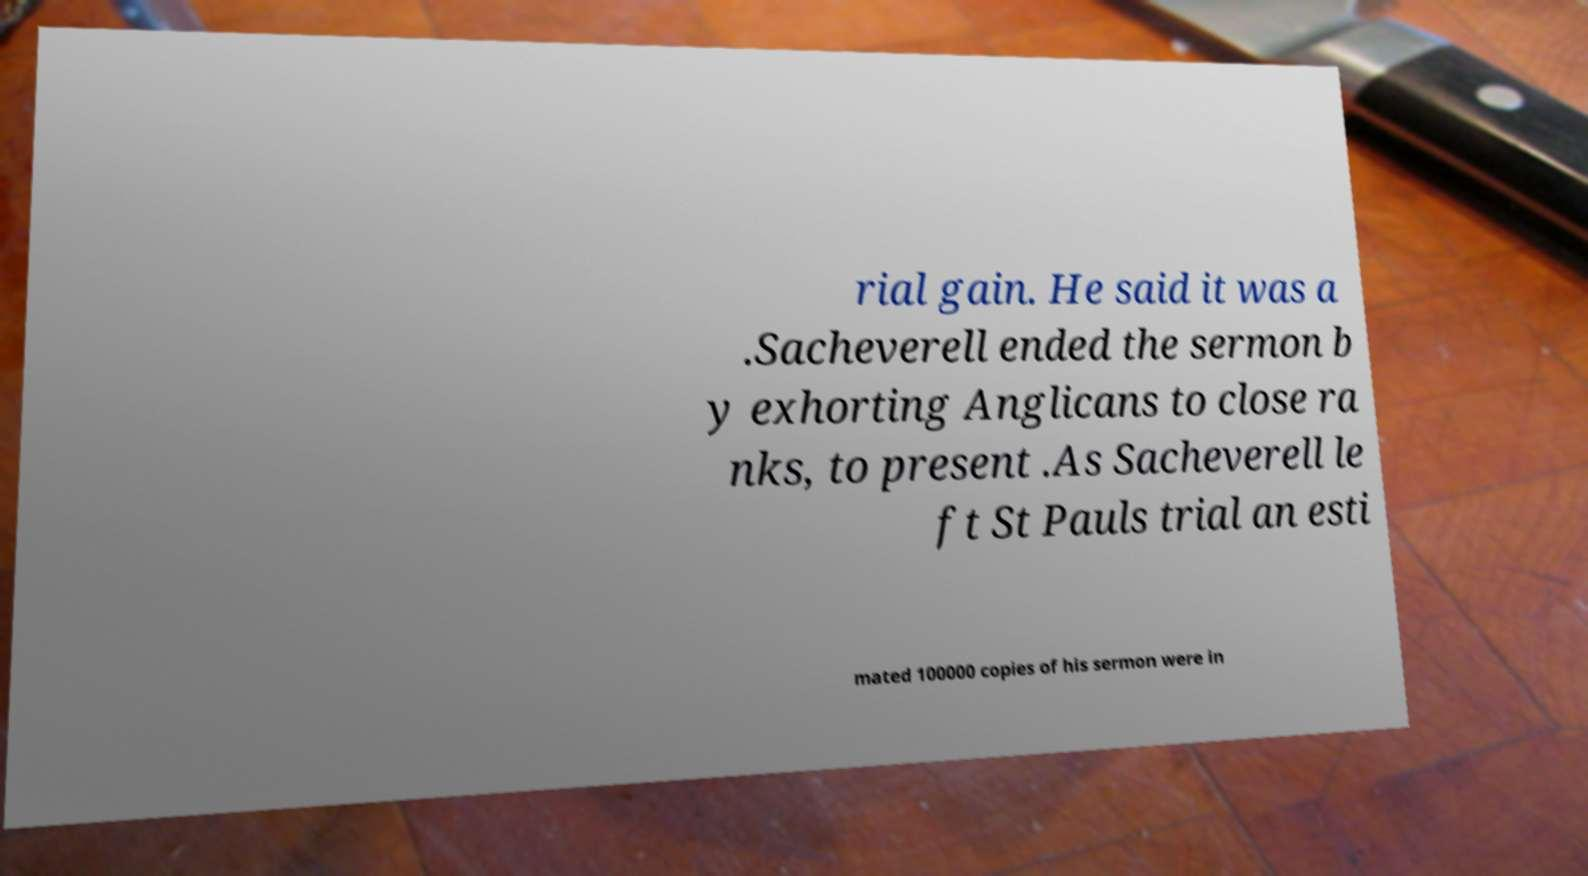For documentation purposes, I need the text within this image transcribed. Could you provide that? rial gain. He said it was a .Sacheverell ended the sermon b y exhorting Anglicans to close ra nks, to present .As Sacheverell le ft St Pauls trial an esti mated 100000 copies of his sermon were in 